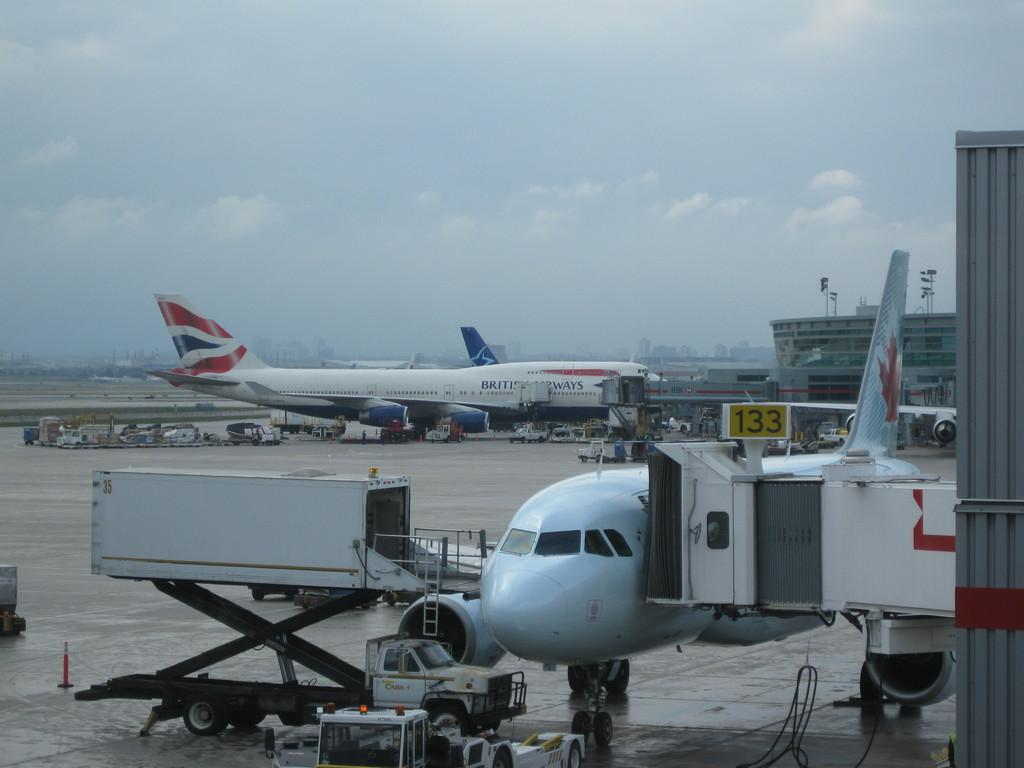Provide a one-sentence caption for the provided image. It's a gloomy day on the tarmac, where commercial Canadian and British Airways jets are connected to covered, portable walkways for passengers to board the planes are parked. 